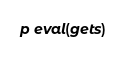<code> <loc_0><loc_0><loc_500><loc_500><_Ruby_>p eval(gets)
</code> 